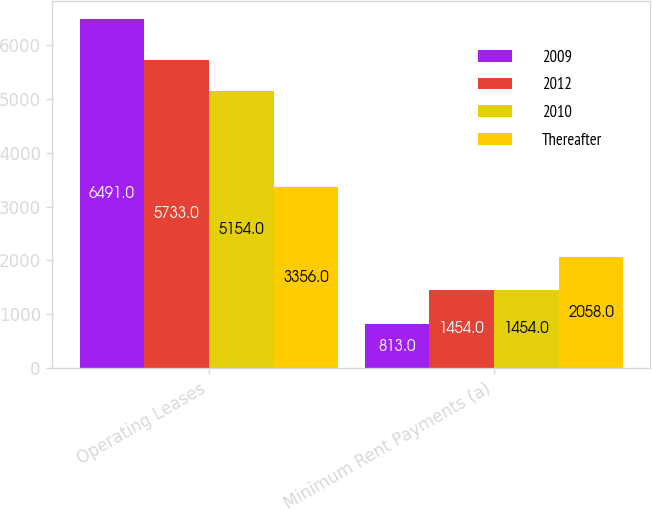Convert chart to OTSL. <chart><loc_0><loc_0><loc_500><loc_500><stacked_bar_chart><ecel><fcel>Operating Leases<fcel>Minimum Rent Payments (a)<nl><fcel>2009<fcel>6491<fcel>813<nl><fcel>2012<fcel>5733<fcel>1454<nl><fcel>2010<fcel>5154<fcel>1454<nl><fcel>Thereafter<fcel>3356<fcel>2058<nl></chart> 